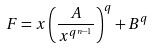Convert formula to latex. <formula><loc_0><loc_0><loc_500><loc_500>F = x \left ( \frac { A } { x ^ { q ^ { n - 1 } } } \right ) ^ { q } + B ^ { q }</formula> 